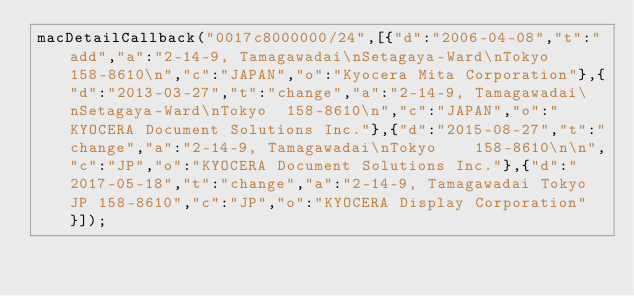<code> <loc_0><loc_0><loc_500><loc_500><_JavaScript_>macDetailCallback("0017c8000000/24",[{"d":"2006-04-08","t":"add","a":"2-14-9, Tamagawadai\nSetagaya-Ward\nTokyo  158-8610\n","c":"JAPAN","o":"Kyocera Mita Corporation"},{"d":"2013-03-27","t":"change","a":"2-14-9, Tamagawadai\nSetagaya-Ward\nTokyo  158-8610\n","c":"JAPAN","o":"KYOCERA Document Solutions Inc."},{"d":"2015-08-27","t":"change","a":"2-14-9, Tamagawadai\nTokyo    158-8610\n\n","c":"JP","o":"KYOCERA Document Solutions Inc."},{"d":"2017-05-18","t":"change","a":"2-14-9, Tamagawadai Tokyo  JP 158-8610","c":"JP","o":"KYOCERA Display Corporation"}]);
</code> 